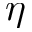Convert formula to latex. <formula><loc_0><loc_0><loc_500><loc_500>\eta</formula> 